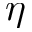Convert formula to latex. <formula><loc_0><loc_0><loc_500><loc_500>\eta</formula> 